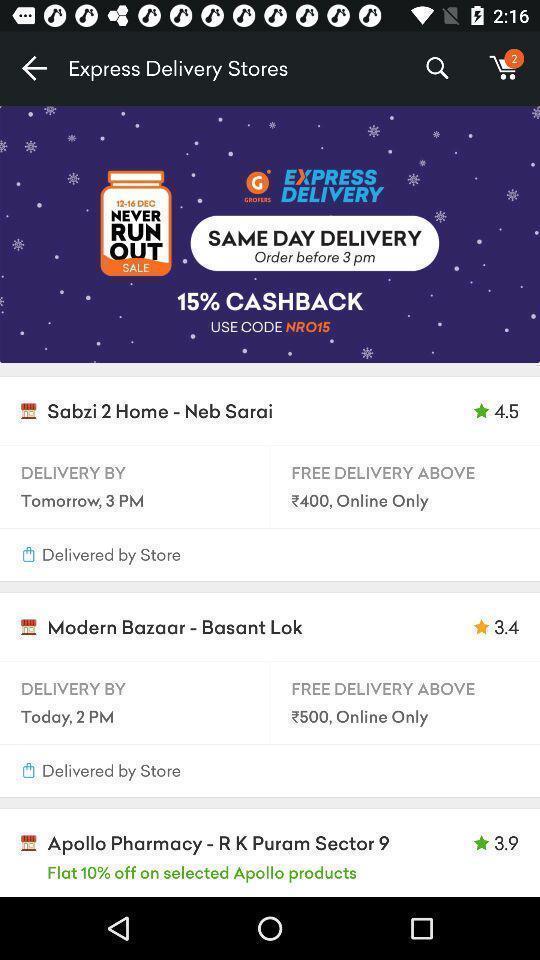Give me a summary of this screen capture. Page showing different stores with delivery details of shopping app. 